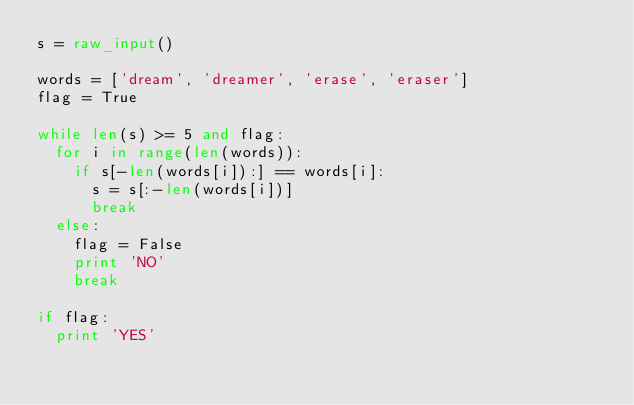<code> <loc_0><loc_0><loc_500><loc_500><_Python_>s = raw_input()

words = ['dream', 'dreamer', 'erase', 'eraser']
flag = True

while len(s) >= 5 and flag:
  for i in range(len(words)):
    if s[-len(words[i]):] == words[i]:
      s = s[:-len(words[i])]
      break
  else:
    flag = False
    print 'NO'
    break

if flag:
  print 'YES'
</code> 